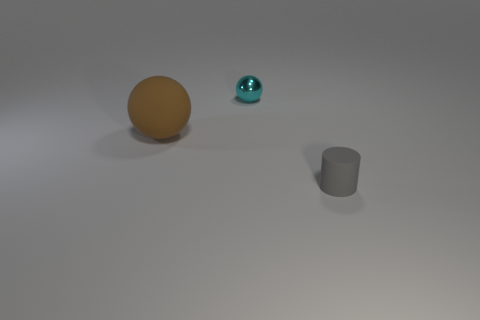Add 1 shiny spheres. How many objects exist? 4 Subtract all cylinders. How many objects are left? 2 Subtract all big yellow metal spheres. Subtract all cyan objects. How many objects are left? 2 Add 1 tiny cyan balls. How many tiny cyan balls are left? 2 Add 1 spheres. How many spheres exist? 3 Subtract 0 blue balls. How many objects are left? 3 